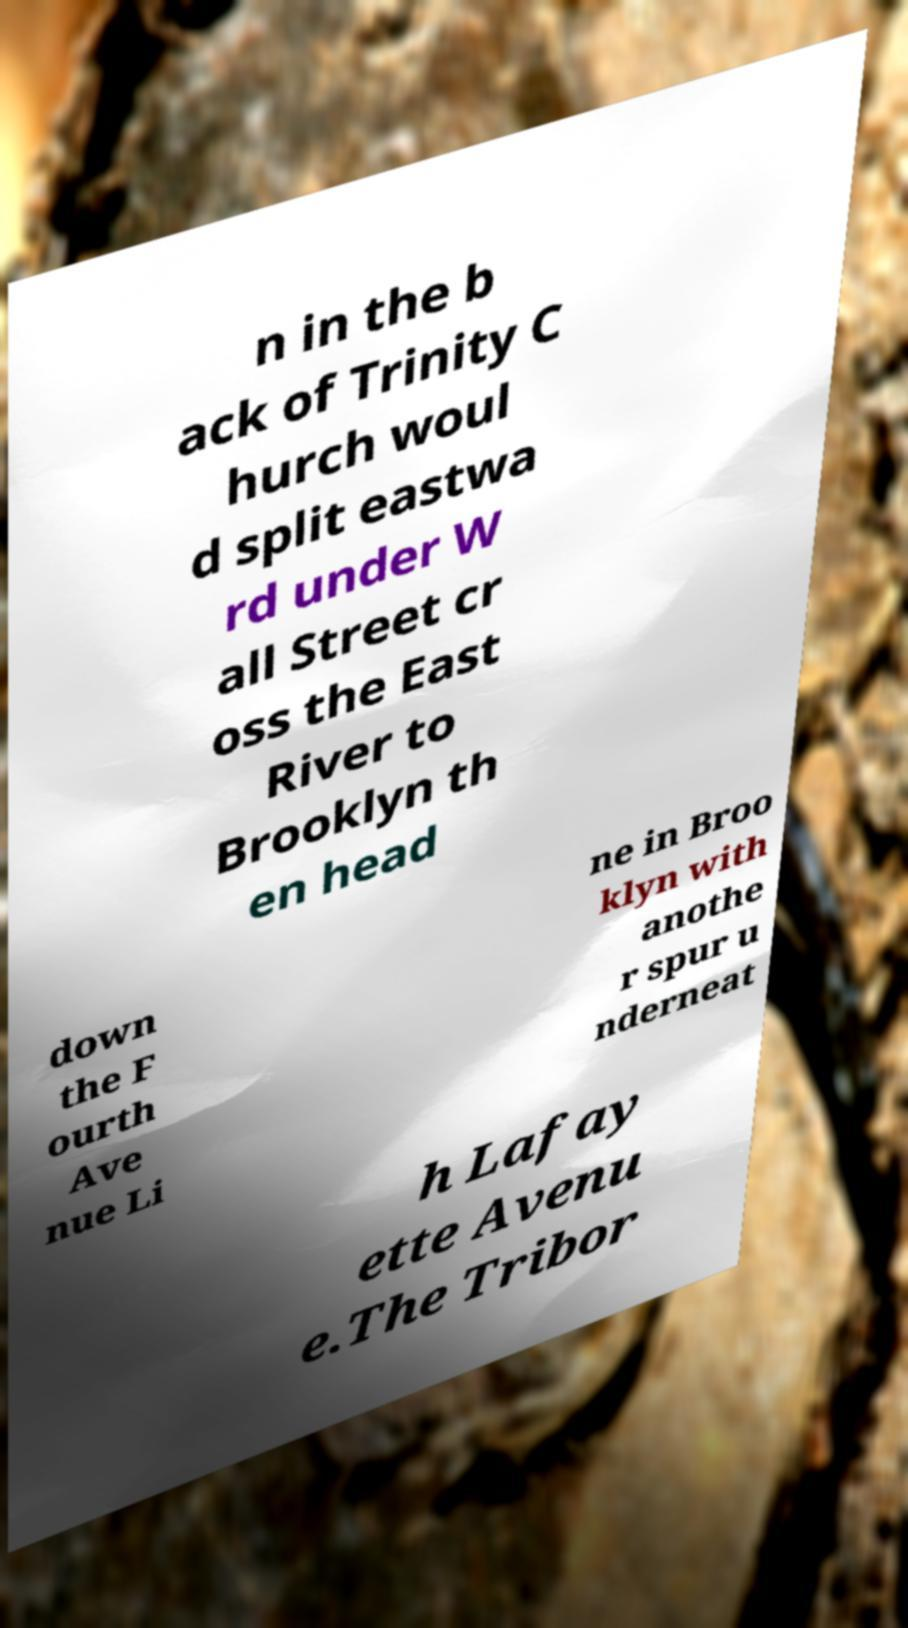Could you assist in decoding the text presented in this image and type it out clearly? n in the b ack of Trinity C hurch woul d split eastwa rd under W all Street cr oss the East River to Brooklyn th en head down the F ourth Ave nue Li ne in Broo klyn with anothe r spur u nderneat h Lafay ette Avenu e.The Tribor 